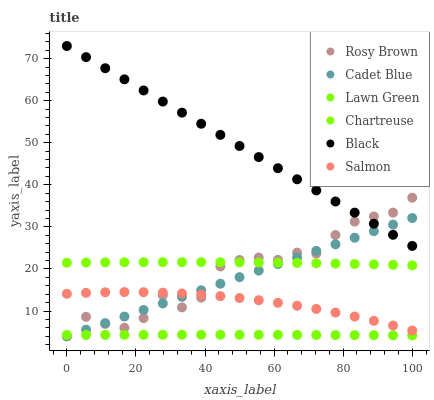Does Lawn Green have the minimum area under the curve?
Answer yes or no. Yes. Does Black have the maximum area under the curve?
Answer yes or no. Yes. Does Cadet Blue have the minimum area under the curve?
Answer yes or no. No. Does Cadet Blue have the maximum area under the curve?
Answer yes or no. No. Is Cadet Blue the smoothest?
Answer yes or no. Yes. Is Rosy Brown the roughest?
Answer yes or no. Yes. Is Rosy Brown the smoothest?
Answer yes or no. No. Is Cadet Blue the roughest?
Answer yes or no. No. Does Cadet Blue have the lowest value?
Answer yes or no. Yes. Does Salmon have the lowest value?
Answer yes or no. No. Does Black have the highest value?
Answer yes or no. Yes. Does Cadet Blue have the highest value?
Answer yes or no. No. Is Salmon less than Black?
Answer yes or no. Yes. Is Black greater than Salmon?
Answer yes or no. Yes. Does Rosy Brown intersect Cadet Blue?
Answer yes or no. Yes. Is Rosy Brown less than Cadet Blue?
Answer yes or no. No. Is Rosy Brown greater than Cadet Blue?
Answer yes or no. No. Does Salmon intersect Black?
Answer yes or no. No. 